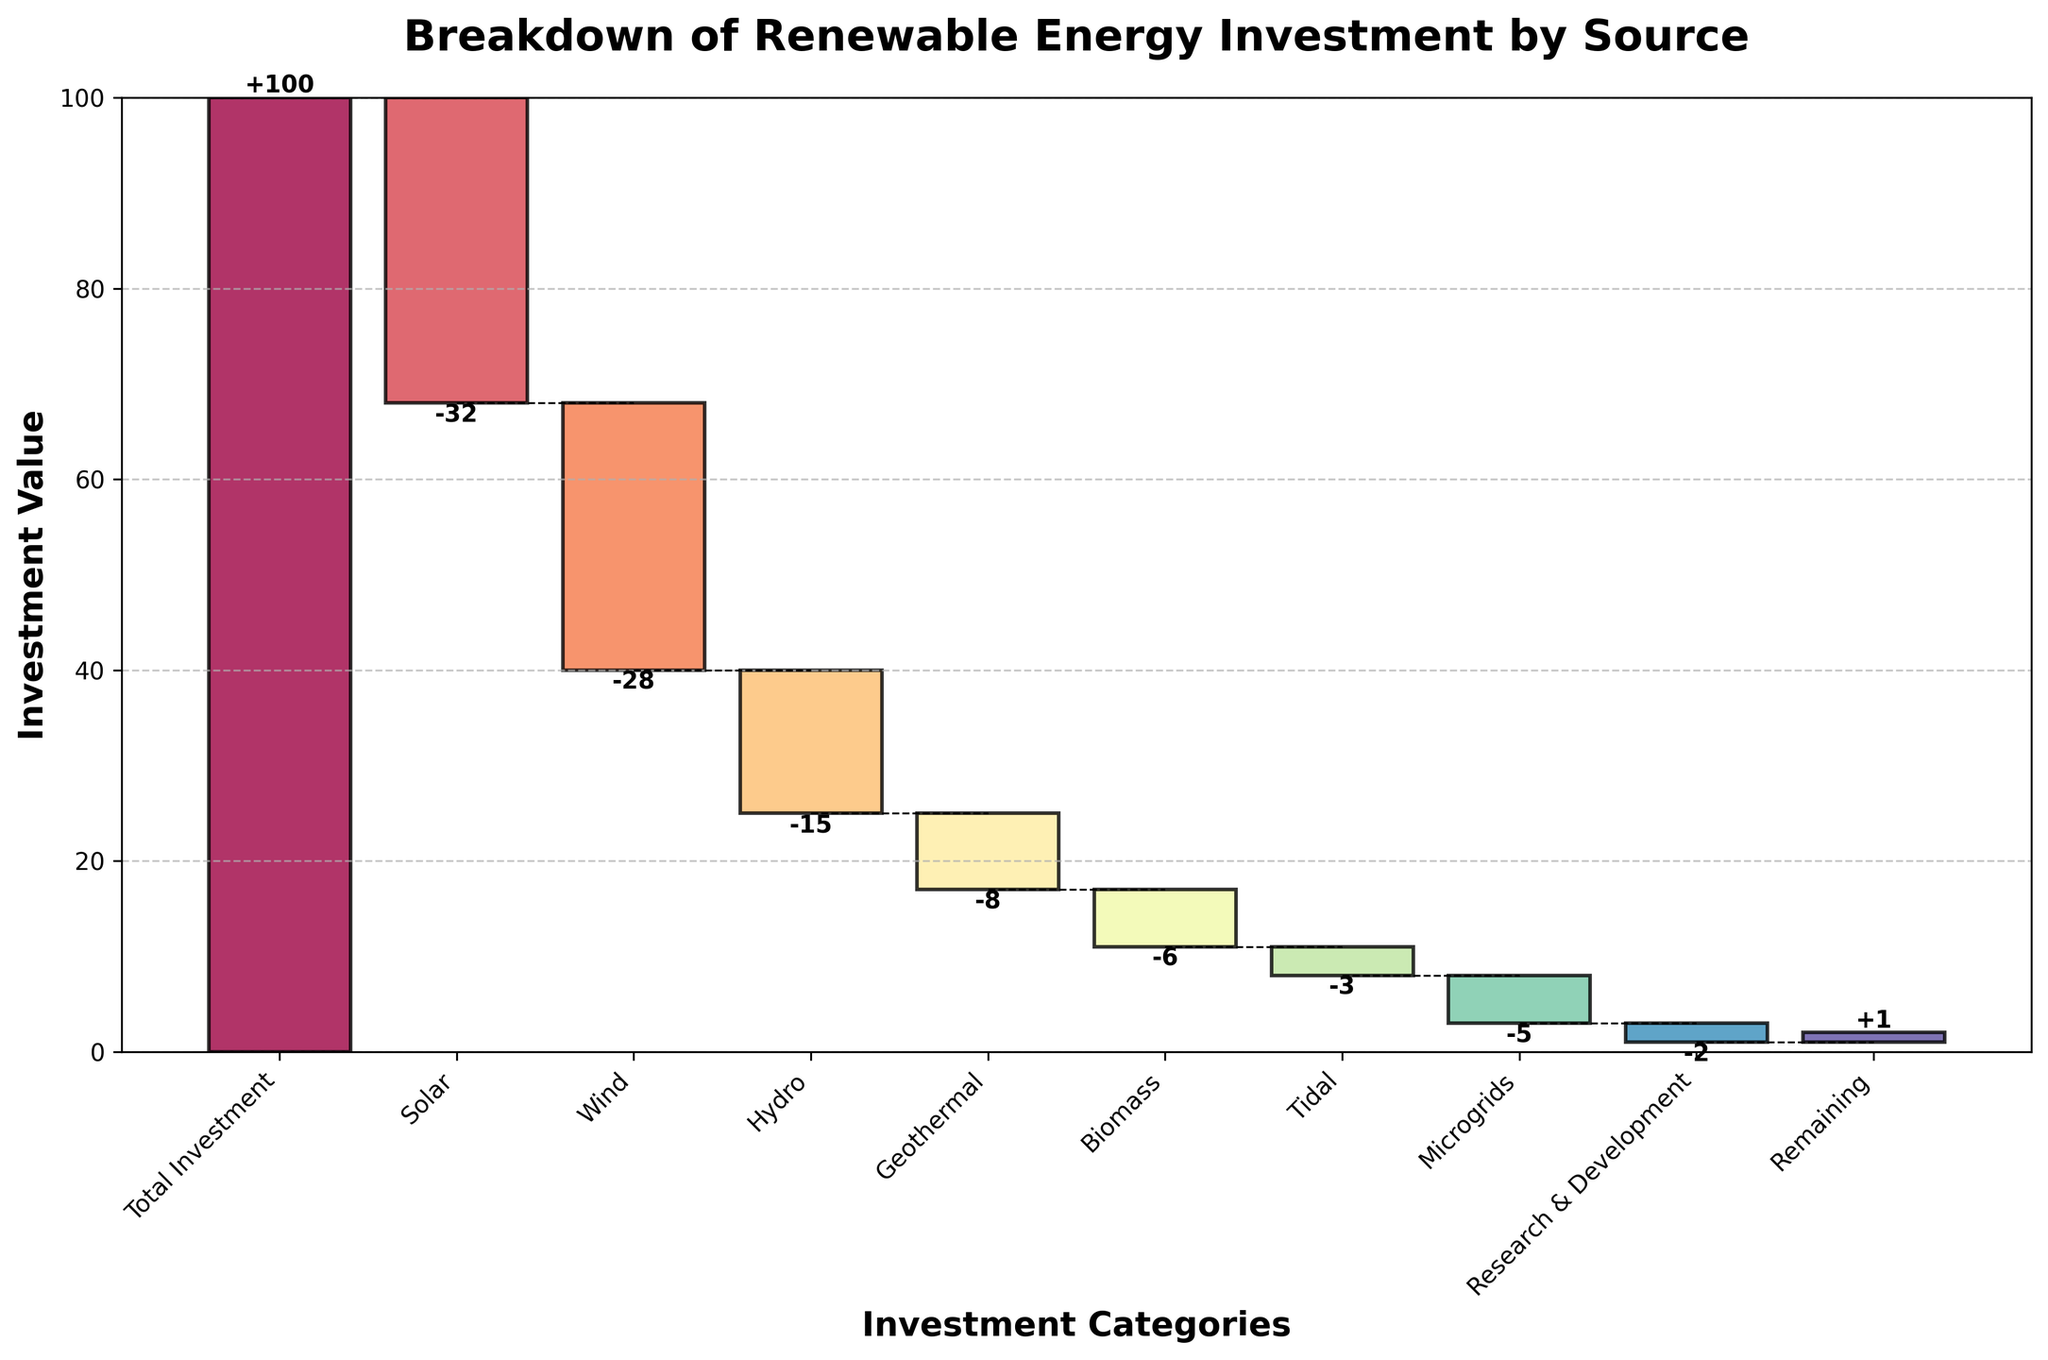Which category receives the largest investment reduction? The largest negative value in the dataset indicates the category with the largest investment reduction. Here, Solar has the largest negative value of -32.
Answer: Solar What is the total investment value? The first bar on the chart represents the total investment value, which is labeled as the "Total Investment." This value is 100.
Answer: 100 How much investment is allocated to Microgrids? Locate the category labeled "Microgrids" in the chart and refer to its associated value. Microgrids have a value of -5.
Answer: -5 What is the combined investment amount for Wind and Hydro? Find the values for Wind and Hydro. Wind has -28 and Hydro has -15. Sum these values: -28 + -15 = -43.
Answer: -43 Which category has the smallest investment reduction? The category with the smallest negative value (closest to zero) has the smallest investment reduction. Tidal has the smallest investment reduction with a value of -3.
Answer: Tidal Compare the investment values between Research & Development and Biomass. Which one has a greater reduction? Research & Development has a value of -2 and Biomass has a value of -6. Since -6 is less than -2, Biomass has a greater reduction.
Answer: Biomass What is the cumulative investment value after accounting for Solar and Wind? The cumulative value after Solar is 100 - 32 = 68, and then after Wind is 68 - 28 = 40.
Answer: 40 What is the incremental contribution of the Geothermal category to the overall investment? Geothermal has a value of -8, which means it reduces the total investment by 8 units.
Answer: -8 